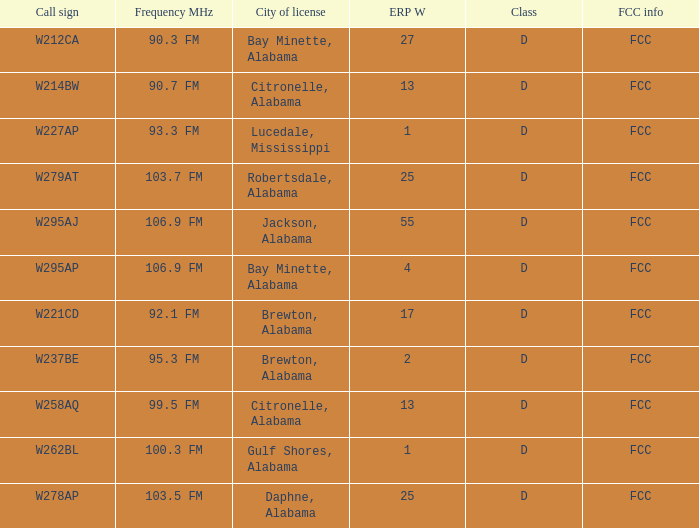3 fm's frequency in mhz. Bay Minette, Alabama. 